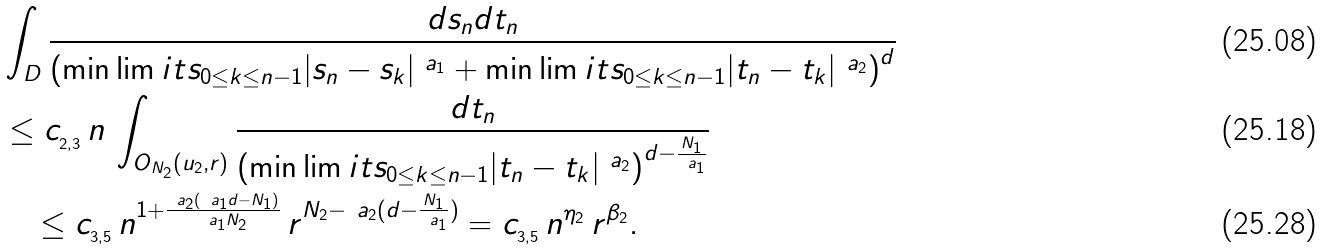<formula> <loc_0><loc_0><loc_500><loc_500>& \int _ { D } \frac { d s _ { n } d t _ { n } } { \left ( \min \lim i t s _ { 0 \leq k \leq n - 1 } | s _ { n } - s _ { k } | ^ { \ a _ { 1 } } + \min \lim i t s _ { 0 \leq k \leq n - 1 } | t _ { n } - t _ { k } | ^ { \ a _ { 2 } } \right ) ^ { d } } \\ & \leq c _ { _ { 2 , 3 } } \, n \, \int _ { O _ { N _ { 2 } } ( u _ { 2 } , r ) } \frac { d t _ { n } } { \left ( \min \lim i t s _ { 0 \leq k \leq n - 1 } | t _ { n } - t _ { k } | ^ { \ a _ { 2 } } \right ) ^ { d - \frac { N _ { 1 } } { \ a _ { 1 } } } } \\ & \quad \leq c _ { _ { 3 , 5 } } \, n ^ { 1 + \frac { \ a _ { 2 } ( \ a _ { 1 } d - N _ { 1 } ) } { \ a _ { 1 } N _ { 2 } } } \, r ^ { N _ { 2 } - \ a _ { 2 } ( d - \frac { N _ { 1 } } { \ a _ { 1 } } ) } = c _ { _ { 3 , 5 } } \, n ^ { \eta _ { 2 } } \, r ^ { \beta _ { 2 } } .</formula> 